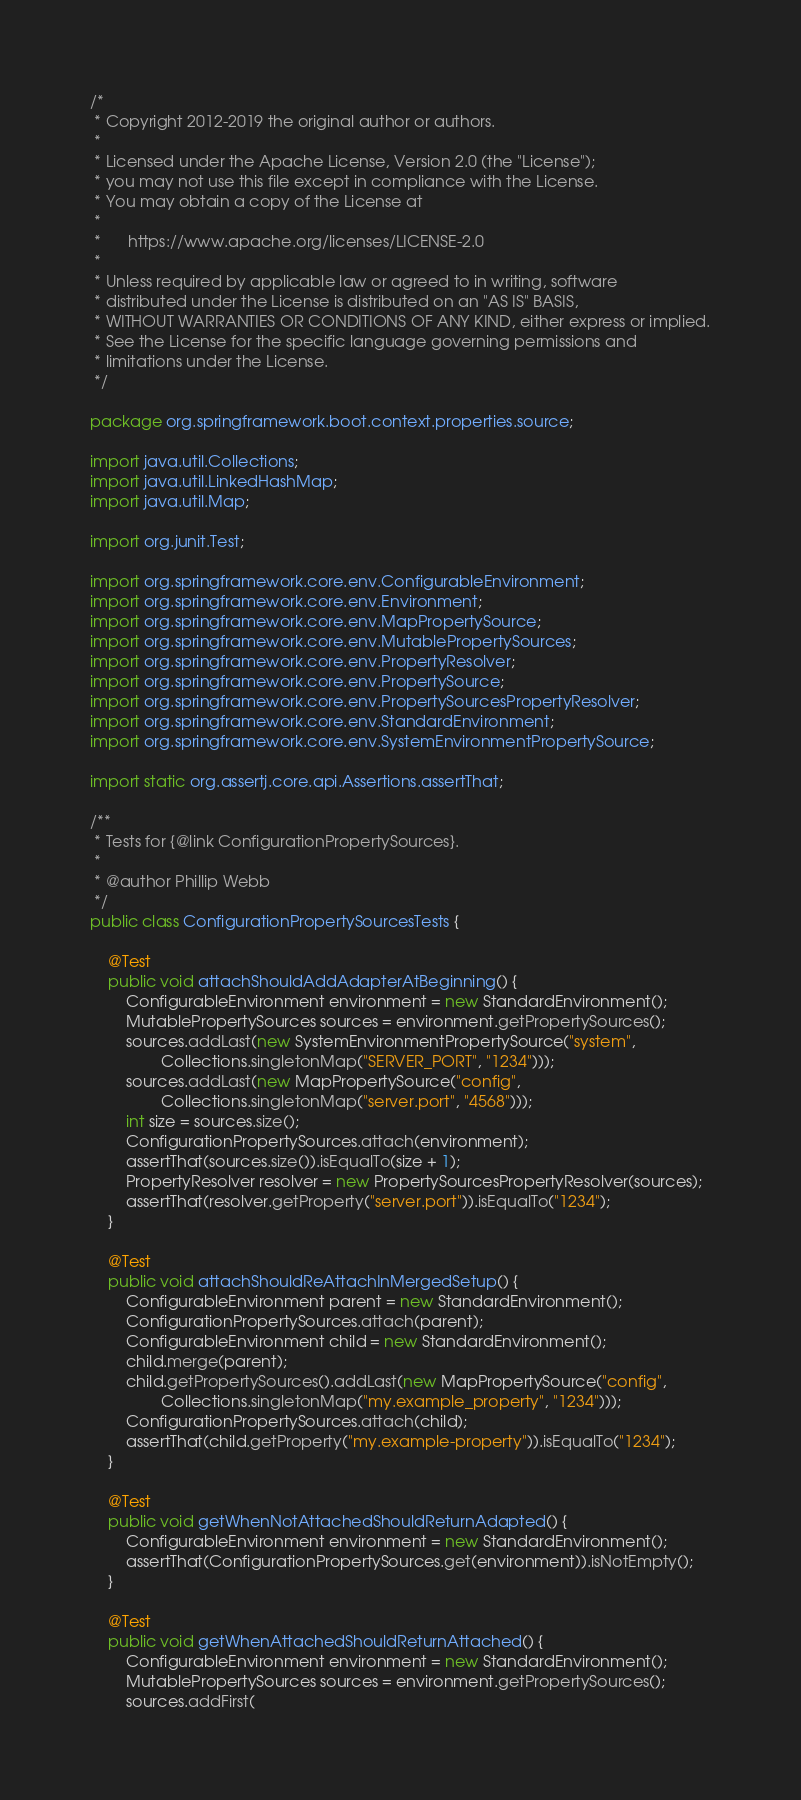Convert code to text. <code><loc_0><loc_0><loc_500><loc_500><_Java_>/*
 * Copyright 2012-2019 the original author or authors.
 *
 * Licensed under the Apache License, Version 2.0 (the "License");
 * you may not use this file except in compliance with the License.
 * You may obtain a copy of the License at
 *
 *      https://www.apache.org/licenses/LICENSE-2.0
 *
 * Unless required by applicable law or agreed to in writing, software
 * distributed under the License is distributed on an "AS IS" BASIS,
 * WITHOUT WARRANTIES OR CONDITIONS OF ANY KIND, either express or implied.
 * See the License for the specific language governing permissions and
 * limitations under the License.
 */

package org.springframework.boot.context.properties.source;

import java.util.Collections;
import java.util.LinkedHashMap;
import java.util.Map;

import org.junit.Test;

import org.springframework.core.env.ConfigurableEnvironment;
import org.springframework.core.env.Environment;
import org.springframework.core.env.MapPropertySource;
import org.springframework.core.env.MutablePropertySources;
import org.springframework.core.env.PropertyResolver;
import org.springframework.core.env.PropertySource;
import org.springframework.core.env.PropertySourcesPropertyResolver;
import org.springframework.core.env.StandardEnvironment;
import org.springframework.core.env.SystemEnvironmentPropertySource;

import static org.assertj.core.api.Assertions.assertThat;

/**
 * Tests for {@link ConfigurationPropertySources}.
 *
 * @author Phillip Webb
 */
public class ConfigurationPropertySourcesTests {

	@Test
	public void attachShouldAddAdapterAtBeginning() {
		ConfigurableEnvironment environment = new StandardEnvironment();
		MutablePropertySources sources = environment.getPropertySources();
		sources.addLast(new SystemEnvironmentPropertySource("system",
				Collections.singletonMap("SERVER_PORT", "1234")));
		sources.addLast(new MapPropertySource("config",
				Collections.singletonMap("server.port", "4568")));
		int size = sources.size();
		ConfigurationPropertySources.attach(environment);
		assertThat(sources.size()).isEqualTo(size + 1);
		PropertyResolver resolver = new PropertySourcesPropertyResolver(sources);
		assertThat(resolver.getProperty("server.port")).isEqualTo("1234");
	}

	@Test
	public void attachShouldReAttachInMergedSetup() {
		ConfigurableEnvironment parent = new StandardEnvironment();
		ConfigurationPropertySources.attach(parent);
		ConfigurableEnvironment child = new StandardEnvironment();
		child.merge(parent);
		child.getPropertySources().addLast(new MapPropertySource("config",
				Collections.singletonMap("my.example_property", "1234")));
		ConfigurationPropertySources.attach(child);
		assertThat(child.getProperty("my.example-property")).isEqualTo("1234");
	}

	@Test
	public void getWhenNotAttachedShouldReturnAdapted() {
		ConfigurableEnvironment environment = new StandardEnvironment();
		assertThat(ConfigurationPropertySources.get(environment)).isNotEmpty();
	}

	@Test
	public void getWhenAttachedShouldReturnAttached() {
		ConfigurableEnvironment environment = new StandardEnvironment();
		MutablePropertySources sources = environment.getPropertySources();
		sources.addFirst(</code> 